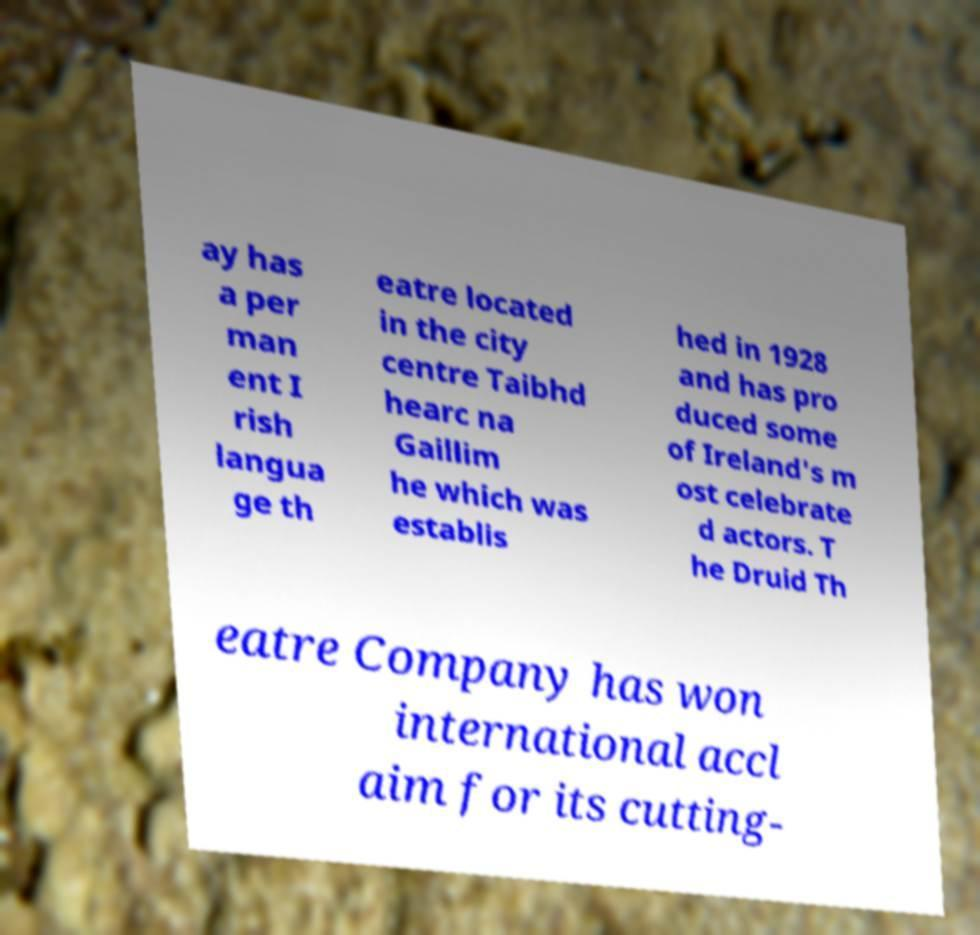For documentation purposes, I need the text within this image transcribed. Could you provide that? ay has a per man ent I rish langua ge th eatre located in the city centre Taibhd hearc na Gaillim he which was establis hed in 1928 and has pro duced some of Ireland's m ost celebrate d actors. T he Druid Th eatre Company has won international accl aim for its cutting- 